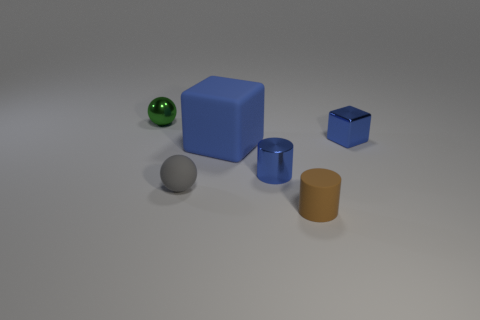Add 1 large brown spheres. How many objects exist? 7 Subtract all balls. How many objects are left? 4 Subtract 1 cylinders. How many cylinders are left? 1 Add 4 big cyan cylinders. How many big cyan cylinders exist? 4 Subtract 0 brown blocks. How many objects are left? 6 Subtract all green cubes. Subtract all green cylinders. How many cubes are left? 2 Subtract all balls. Subtract all small blue matte things. How many objects are left? 4 Add 6 tiny brown cylinders. How many tiny brown cylinders are left? 7 